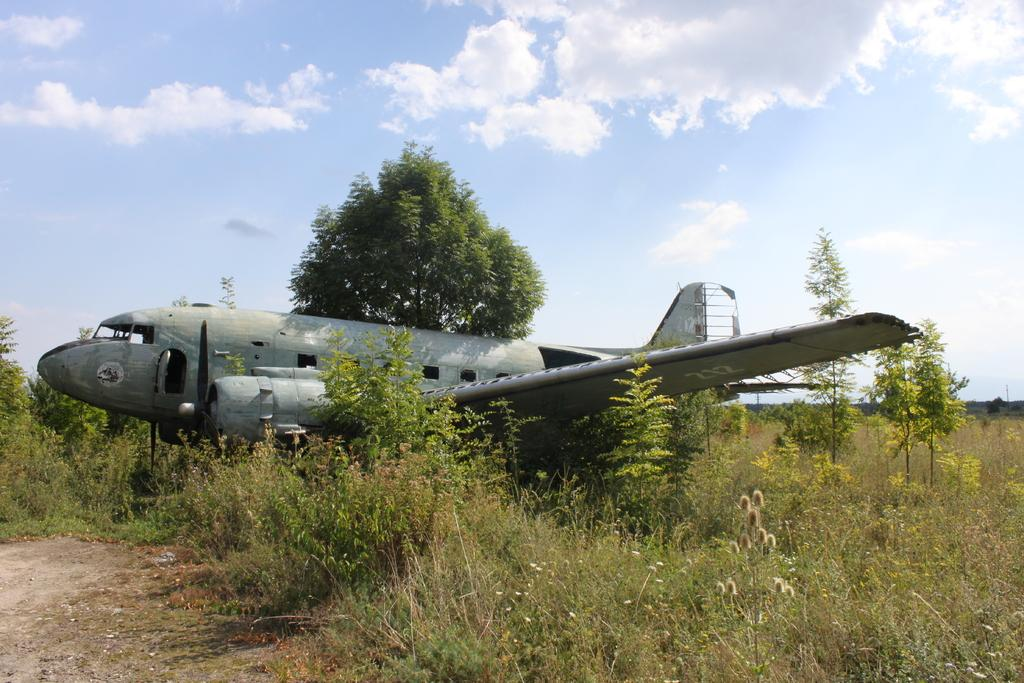What is the main subject of the image? The main subject of the image is an airplane on the ground. What type of vegetation can be seen in the image? There are plants, bushes, and trees in the image. What is visible in the background of the image? The sky is visible in the image. How many geese are flying in the image? There are no geese present in the image. Can you describe the bite marks on the airplane in the image? There are no bite marks visible on the airplane in the image. 